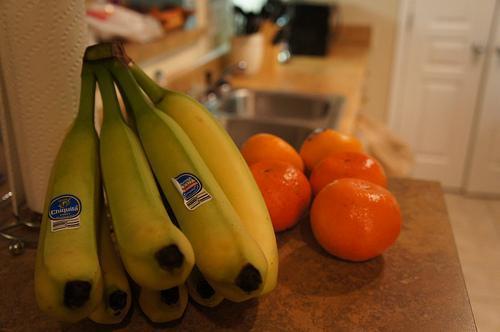How many types of fruit are there?
Give a very brief answer. 2. How many oranges are there?
Give a very brief answer. 5. How many bananas are there?
Give a very brief answer. 7. 